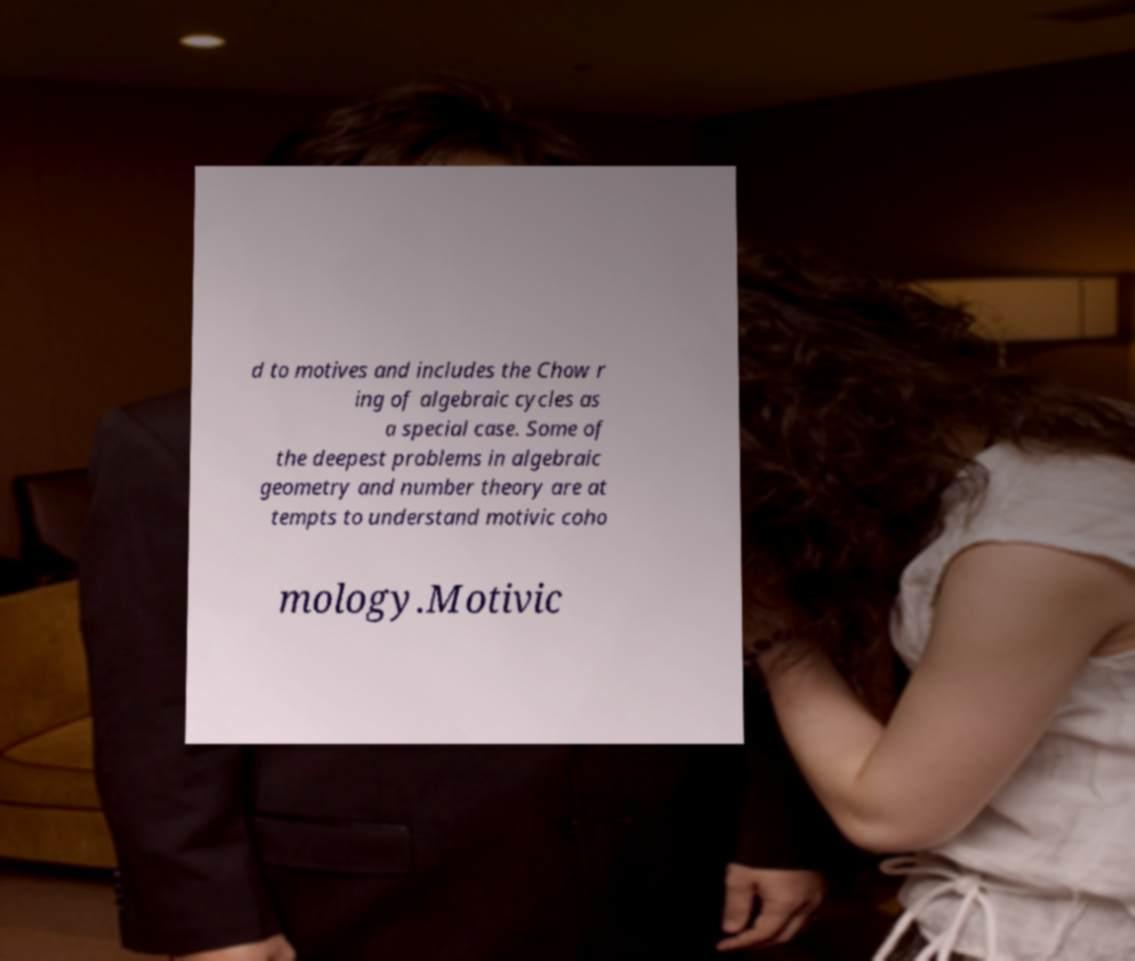There's text embedded in this image that I need extracted. Can you transcribe it verbatim? d to motives and includes the Chow r ing of algebraic cycles as a special case. Some of the deepest problems in algebraic geometry and number theory are at tempts to understand motivic coho mology.Motivic 